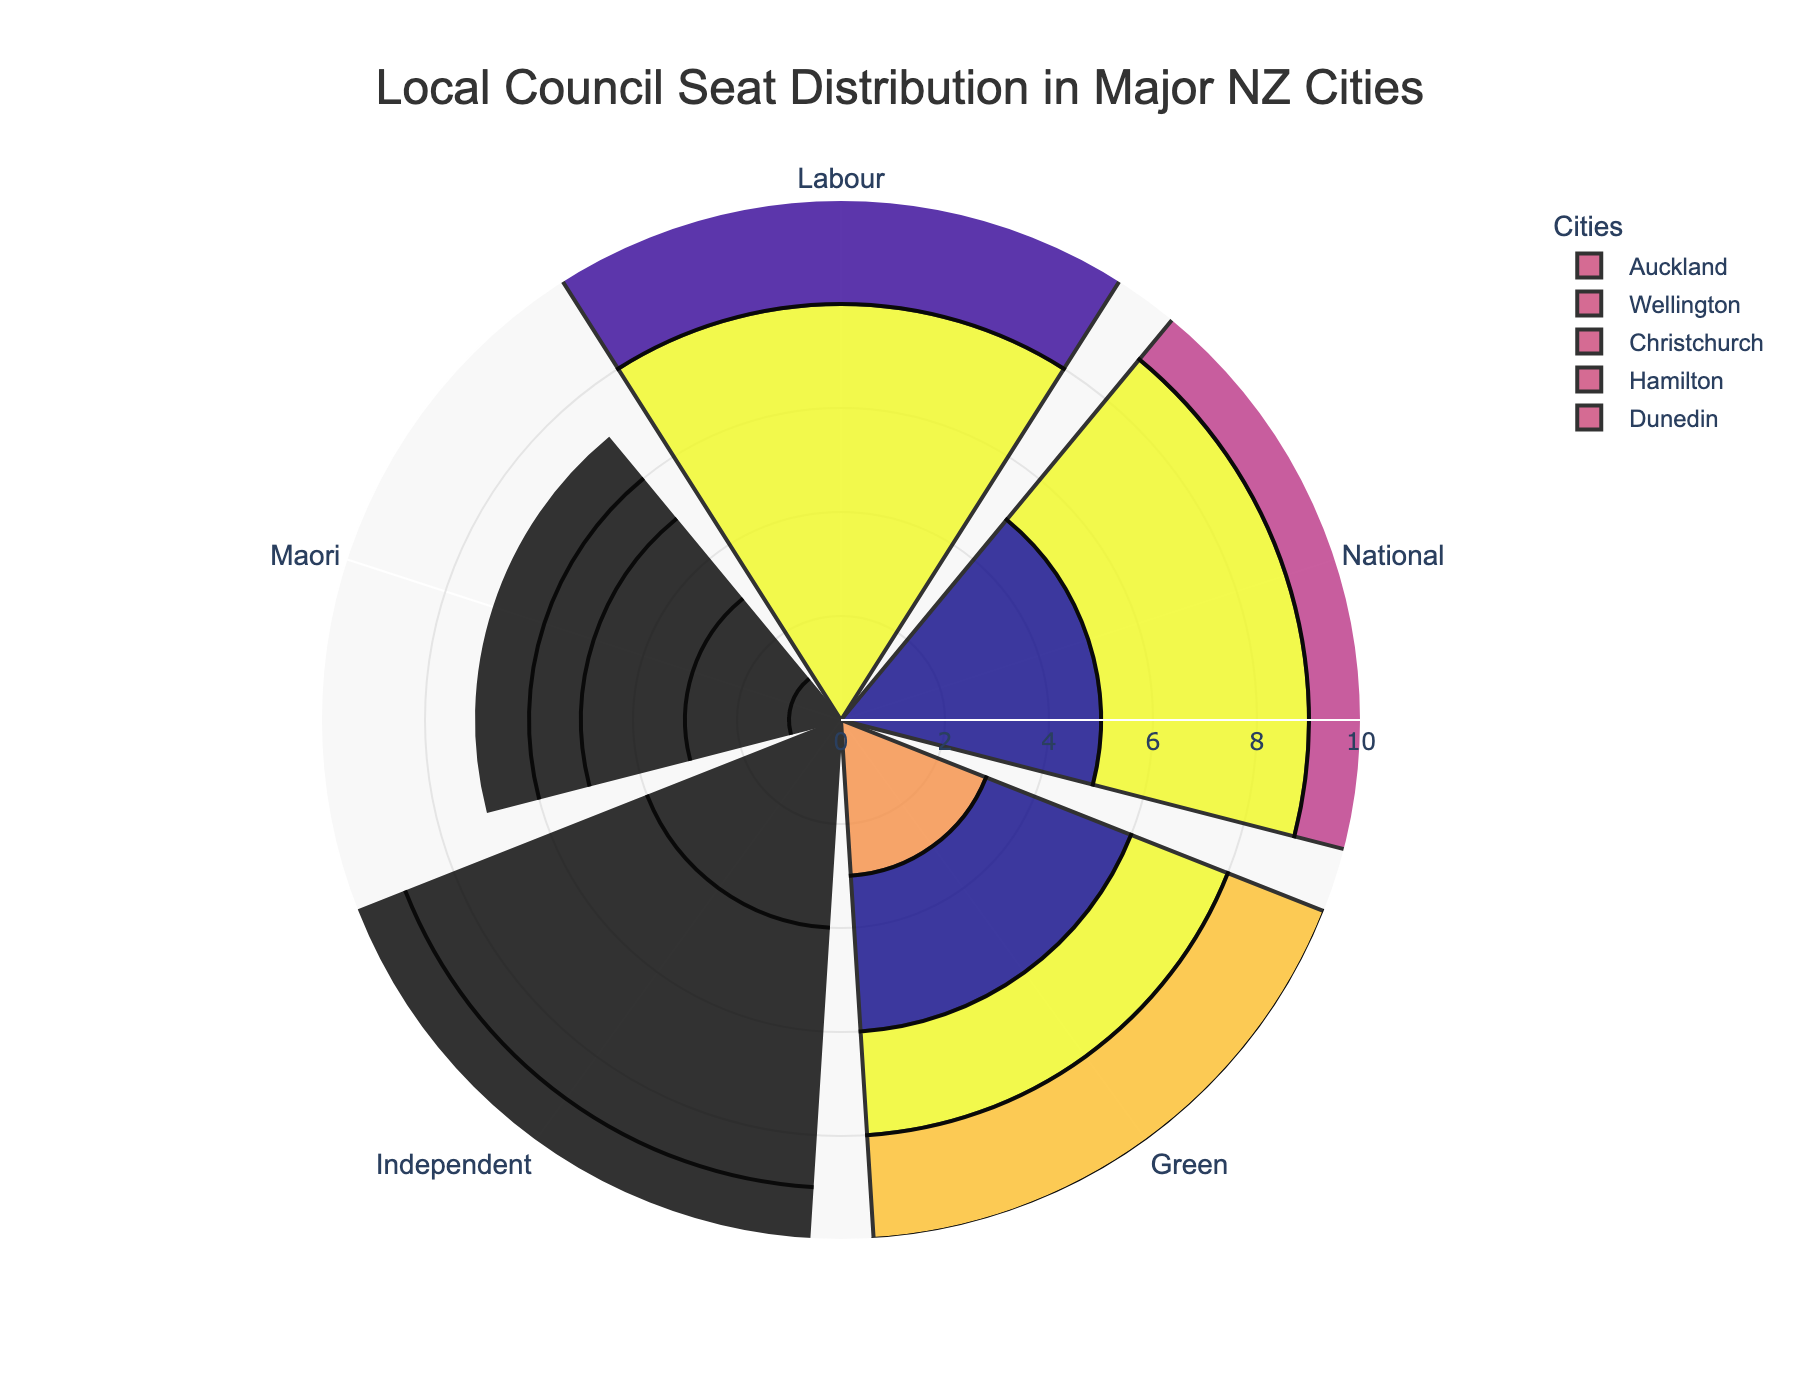What's the primary title of the rose chart? The title of the chart is located at the top and it summarizes the main topic of the visualization, which helps the audience understand the overall theme.
Answer: Local Council Seat Distribution in Major NZ Cities Which city has the highest number of seats for the Labour party? Check each city's Labour slice on the radial scale to determine which goes the furthest. Auckland's Labour slice extends to 8, which is the highest.
Answer: Auckland How many seats does the National party hold in Wellington and Christchurch combined? Find the National slices for Wellington and Christchurch, then sum their length on the radial scale. Wellington has 4 and Christchurch has 6. Adding them gives 4 + 6 = 10.
Answer: 10 Which party has the least number of seats in Auckland? Look at each slice for Auckland and identify the shortest one. The Maori party slice extends to 1, which is the shortest.
Answer: Maori How does the number of Green party seats in Dunedin compare to those in Auckland? Compare the Green slices of Dunedin and Auckland on the radial scale. Dunedin and Auckland both have 3 seats each, so they are equal.
Answer: Equal What's the average number of seats held by the Independent party across all cities? Sum the Independent seats from each city (4+5+3+3+4 = 19) and divide by the number of cities (5). So, the average is 19/5 = 3.8.
Answer: 3.8 Which city has the most evenly distributed seats among the parties? Look for the city where the slices are closest in length on the radial scale. Dunedin has slices that are fairly close in length.
Answer: Dunedin Is there any city where the Maori party holds more than 1 seat? Check the Maori slices for all cities. Both Wellington and Christchurch have slices extending to 2 seats.
Answer: Yes How many parties have more than 3 seats in Auckland? Check the slices in Auckland, count the parties with slices longer than 3 on the radial scale. There are two: Labour and Independent.
Answer: 2 Which city has the smallest total number of council seats? Sum the radial distances of all slices for each city, and check which total is the lowest. Hamilton has 5+4+2+3+1 = 15 seats, the smallest total.
Answer: Hamilton 